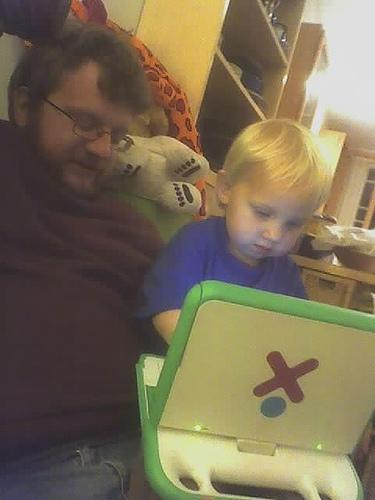What kind of action is the boy taking? typing 